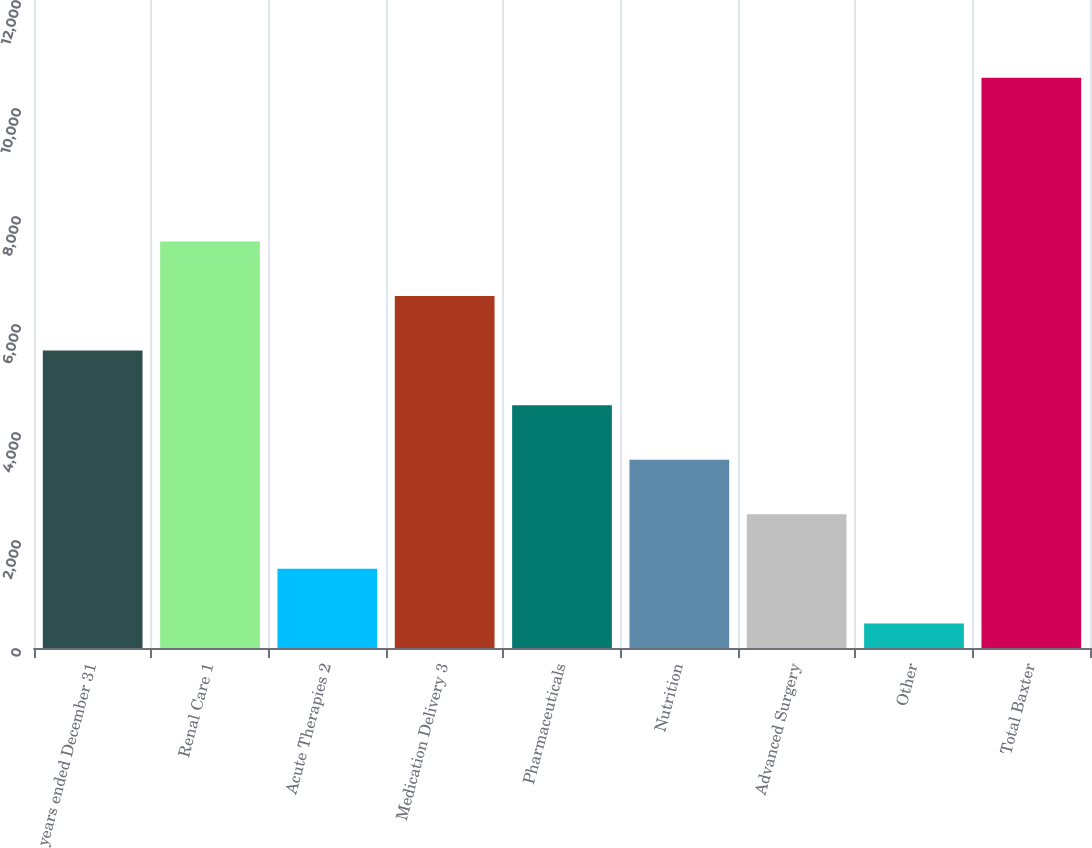<chart> <loc_0><loc_0><loc_500><loc_500><bar_chart><fcel>years ended December 31<fcel>Renal Care 1<fcel>Acute Therapies 2<fcel>Medication Delivery 3<fcel>Pharmaceuticals<fcel>Nutrition<fcel>Advanced Surgery<fcel>Other<fcel>Total Baxter<nl><fcel>5508<fcel>7529.2<fcel>1465.6<fcel>6518.6<fcel>4497.4<fcel>3486.8<fcel>2476.2<fcel>455<fcel>10561<nl></chart> 